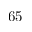Convert formula to latex. <formula><loc_0><loc_0><loc_500><loc_500>6 5</formula> 